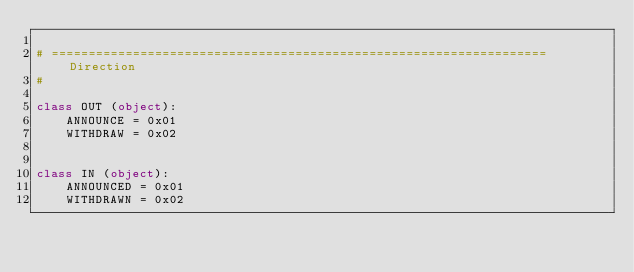Convert code to text. <code><loc_0><loc_0><loc_500><loc_500><_Python_>
# =================================================================== Direction
#

class OUT (object):
	ANNOUNCE = 0x01
	WITHDRAW = 0x02


class IN (object):
	ANNOUNCED = 0x01
	WITHDRAWN = 0x02
</code> 